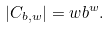<formula> <loc_0><loc_0><loc_500><loc_500>| C _ { b , w } | = w b ^ { w } .</formula> 